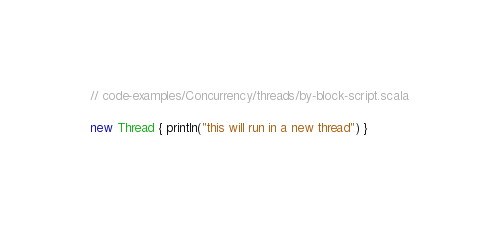Convert code to text. <code><loc_0><loc_0><loc_500><loc_500><_Scala_>// code-examples/Concurrency/threads/by-block-script.scala

new Thread { println("this will run in a new thread") }</code> 